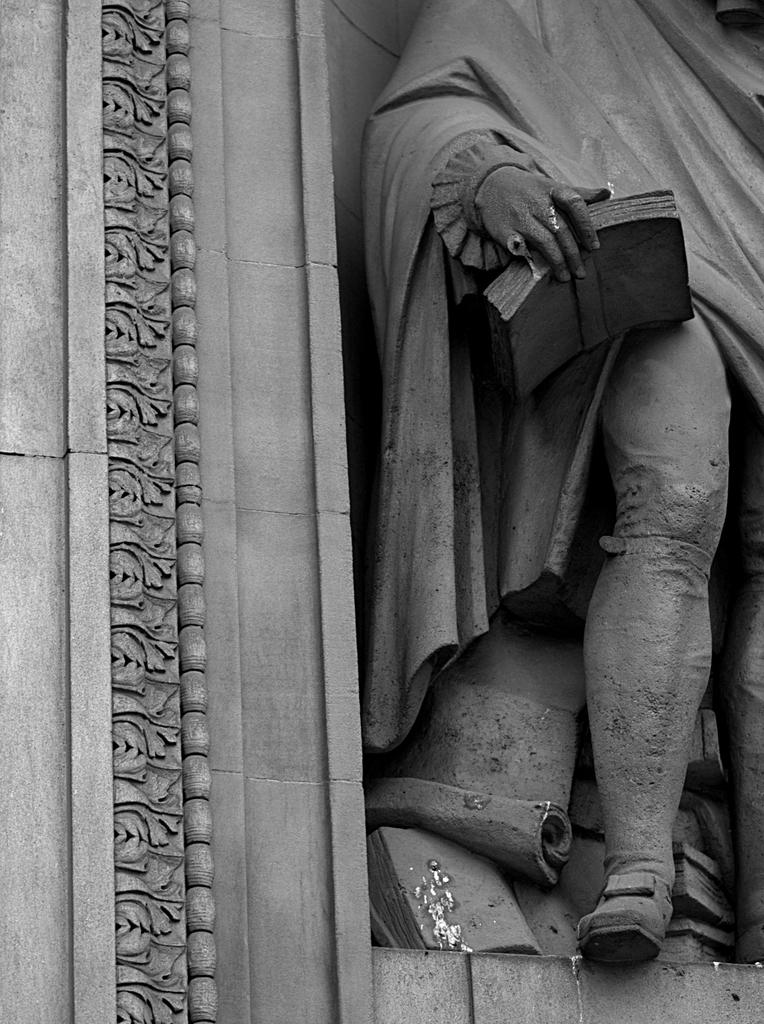What is the color scheme of the image? The image is black and white. What can be seen on the right side of the image? There is a statue on the right side of the image. What is present on the left side of the image? There is carving on the wall on the left side of the image. How many sheep are visible in the image? There are no sheep present in the image. What is the title of the carving on the wall? The provided facts do not mention a title for the carving, so it cannot be determined from the image. 